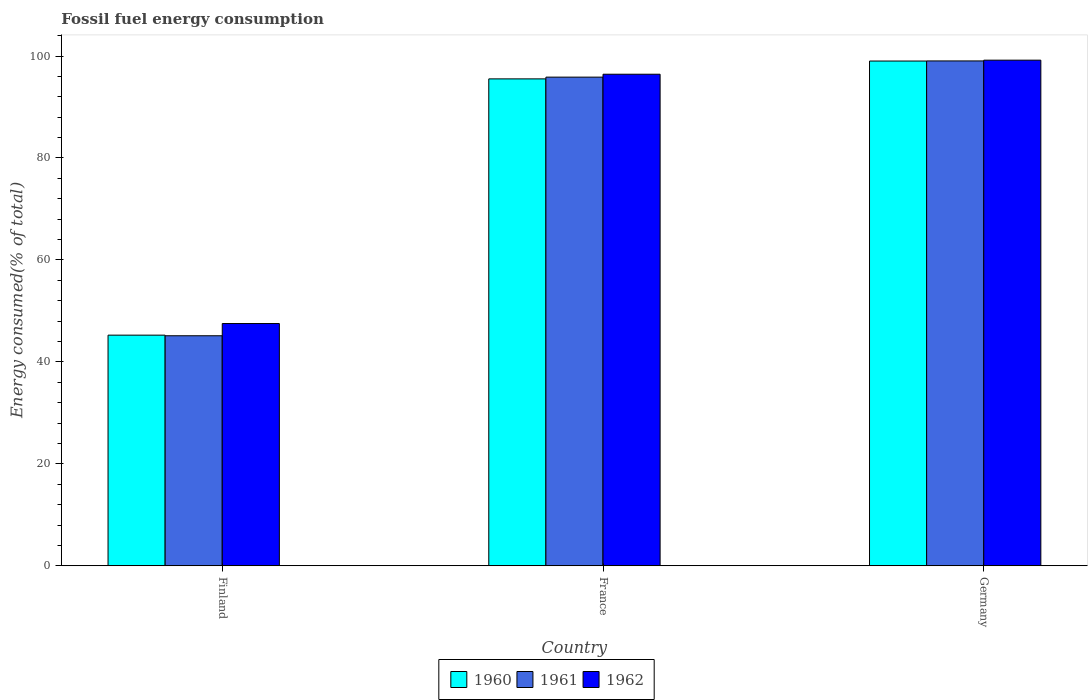How many groups of bars are there?
Make the answer very short. 3. How many bars are there on the 3rd tick from the left?
Give a very brief answer. 3. What is the label of the 3rd group of bars from the left?
Your answer should be compact. Germany. In how many cases, is the number of bars for a given country not equal to the number of legend labels?
Make the answer very short. 0. What is the percentage of energy consumed in 1961 in Germany?
Provide a short and direct response. 99.04. Across all countries, what is the maximum percentage of energy consumed in 1960?
Make the answer very short. 99.02. Across all countries, what is the minimum percentage of energy consumed in 1960?
Your answer should be compact. 45.25. In which country was the percentage of energy consumed in 1962 maximum?
Ensure brevity in your answer.  Germany. In which country was the percentage of energy consumed in 1960 minimum?
Your response must be concise. Finland. What is the total percentage of energy consumed in 1962 in the graph?
Keep it short and to the point. 243.15. What is the difference between the percentage of energy consumed in 1961 in Finland and that in France?
Provide a succinct answer. -50.73. What is the difference between the percentage of energy consumed in 1961 in Germany and the percentage of energy consumed in 1962 in France?
Keep it short and to the point. 2.61. What is the average percentage of energy consumed in 1961 per country?
Ensure brevity in your answer.  80.01. What is the difference between the percentage of energy consumed of/in 1960 and percentage of energy consumed of/in 1962 in Germany?
Give a very brief answer. -0.17. What is the ratio of the percentage of energy consumed in 1961 in France to that in Germany?
Provide a succinct answer. 0.97. What is the difference between the highest and the second highest percentage of energy consumed in 1961?
Offer a very short reply. 53.91. What is the difference between the highest and the lowest percentage of energy consumed in 1962?
Offer a very short reply. 51.67. In how many countries, is the percentage of energy consumed in 1962 greater than the average percentage of energy consumed in 1962 taken over all countries?
Offer a very short reply. 2. Is the sum of the percentage of energy consumed in 1961 in France and Germany greater than the maximum percentage of energy consumed in 1962 across all countries?
Provide a short and direct response. Yes. Are all the bars in the graph horizontal?
Keep it short and to the point. No. Are the values on the major ticks of Y-axis written in scientific E-notation?
Your answer should be compact. No. Does the graph contain any zero values?
Make the answer very short. No. Does the graph contain grids?
Provide a succinct answer. No. How many legend labels are there?
Give a very brief answer. 3. How are the legend labels stacked?
Ensure brevity in your answer.  Horizontal. What is the title of the graph?
Keep it short and to the point. Fossil fuel energy consumption. Does "1978" appear as one of the legend labels in the graph?
Make the answer very short. No. What is the label or title of the X-axis?
Offer a terse response. Country. What is the label or title of the Y-axis?
Give a very brief answer. Energy consumed(% of total). What is the Energy consumed(% of total) in 1960 in Finland?
Keep it short and to the point. 45.25. What is the Energy consumed(% of total) of 1961 in Finland?
Offer a very short reply. 45.13. What is the Energy consumed(% of total) of 1962 in Finland?
Offer a terse response. 47.52. What is the Energy consumed(% of total) of 1960 in France?
Your response must be concise. 95.52. What is the Energy consumed(% of total) in 1961 in France?
Ensure brevity in your answer.  95.86. What is the Energy consumed(% of total) of 1962 in France?
Provide a short and direct response. 96.43. What is the Energy consumed(% of total) in 1960 in Germany?
Make the answer very short. 99.02. What is the Energy consumed(% of total) in 1961 in Germany?
Offer a terse response. 99.04. What is the Energy consumed(% of total) of 1962 in Germany?
Your answer should be compact. 99.19. Across all countries, what is the maximum Energy consumed(% of total) of 1960?
Your response must be concise. 99.02. Across all countries, what is the maximum Energy consumed(% of total) in 1961?
Offer a very short reply. 99.04. Across all countries, what is the maximum Energy consumed(% of total) in 1962?
Keep it short and to the point. 99.19. Across all countries, what is the minimum Energy consumed(% of total) in 1960?
Offer a terse response. 45.25. Across all countries, what is the minimum Energy consumed(% of total) in 1961?
Provide a succinct answer. 45.13. Across all countries, what is the minimum Energy consumed(% of total) of 1962?
Offer a very short reply. 47.52. What is the total Energy consumed(% of total) of 1960 in the graph?
Ensure brevity in your answer.  239.79. What is the total Energy consumed(% of total) in 1961 in the graph?
Keep it short and to the point. 240.03. What is the total Energy consumed(% of total) of 1962 in the graph?
Offer a very short reply. 243.15. What is the difference between the Energy consumed(% of total) in 1960 in Finland and that in France?
Provide a succinct answer. -50.27. What is the difference between the Energy consumed(% of total) of 1961 in Finland and that in France?
Keep it short and to the point. -50.73. What is the difference between the Energy consumed(% of total) of 1962 in Finland and that in France?
Provide a succinct answer. -48.91. What is the difference between the Energy consumed(% of total) in 1960 in Finland and that in Germany?
Your answer should be compact. -53.77. What is the difference between the Energy consumed(% of total) in 1961 in Finland and that in Germany?
Keep it short and to the point. -53.91. What is the difference between the Energy consumed(% of total) of 1962 in Finland and that in Germany?
Offer a terse response. -51.67. What is the difference between the Energy consumed(% of total) in 1961 in France and that in Germany?
Provide a succinct answer. -3.18. What is the difference between the Energy consumed(% of total) in 1962 in France and that in Germany?
Your answer should be compact. -2.76. What is the difference between the Energy consumed(% of total) of 1960 in Finland and the Energy consumed(% of total) of 1961 in France?
Your response must be concise. -50.62. What is the difference between the Energy consumed(% of total) of 1960 in Finland and the Energy consumed(% of total) of 1962 in France?
Ensure brevity in your answer.  -51.19. What is the difference between the Energy consumed(% of total) of 1961 in Finland and the Energy consumed(% of total) of 1962 in France?
Offer a very short reply. -51.3. What is the difference between the Energy consumed(% of total) of 1960 in Finland and the Energy consumed(% of total) of 1961 in Germany?
Ensure brevity in your answer.  -53.8. What is the difference between the Energy consumed(% of total) in 1960 in Finland and the Energy consumed(% of total) in 1962 in Germany?
Your response must be concise. -53.95. What is the difference between the Energy consumed(% of total) of 1961 in Finland and the Energy consumed(% of total) of 1962 in Germany?
Make the answer very short. -54.06. What is the difference between the Energy consumed(% of total) in 1960 in France and the Energy consumed(% of total) in 1961 in Germany?
Offer a terse response. -3.52. What is the difference between the Energy consumed(% of total) in 1960 in France and the Energy consumed(% of total) in 1962 in Germany?
Your answer should be very brief. -3.67. What is the difference between the Energy consumed(% of total) in 1961 in France and the Energy consumed(% of total) in 1962 in Germany?
Keep it short and to the point. -3.33. What is the average Energy consumed(% of total) of 1960 per country?
Offer a very short reply. 79.93. What is the average Energy consumed(% of total) in 1961 per country?
Your answer should be compact. 80.01. What is the average Energy consumed(% of total) of 1962 per country?
Your answer should be compact. 81.05. What is the difference between the Energy consumed(% of total) in 1960 and Energy consumed(% of total) in 1961 in Finland?
Ensure brevity in your answer.  0.12. What is the difference between the Energy consumed(% of total) in 1960 and Energy consumed(% of total) in 1962 in Finland?
Give a very brief answer. -2.28. What is the difference between the Energy consumed(% of total) of 1961 and Energy consumed(% of total) of 1962 in Finland?
Offer a very short reply. -2.4. What is the difference between the Energy consumed(% of total) of 1960 and Energy consumed(% of total) of 1961 in France?
Ensure brevity in your answer.  -0.34. What is the difference between the Energy consumed(% of total) in 1960 and Energy consumed(% of total) in 1962 in France?
Offer a terse response. -0.91. What is the difference between the Energy consumed(% of total) of 1961 and Energy consumed(% of total) of 1962 in France?
Your answer should be compact. -0.57. What is the difference between the Energy consumed(% of total) of 1960 and Energy consumed(% of total) of 1961 in Germany?
Offer a very short reply. -0.02. What is the difference between the Energy consumed(% of total) of 1960 and Energy consumed(% of total) of 1962 in Germany?
Offer a very short reply. -0.17. What is the difference between the Energy consumed(% of total) in 1961 and Energy consumed(% of total) in 1962 in Germany?
Provide a short and direct response. -0.15. What is the ratio of the Energy consumed(% of total) of 1960 in Finland to that in France?
Provide a short and direct response. 0.47. What is the ratio of the Energy consumed(% of total) in 1961 in Finland to that in France?
Your answer should be compact. 0.47. What is the ratio of the Energy consumed(% of total) in 1962 in Finland to that in France?
Offer a very short reply. 0.49. What is the ratio of the Energy consumed(% of total) in 1960 in Finland to that in Germany?
Make the answer very short. 0.46. What is the ratio of the Energy consumed(% of total) in 1961 in Finland to that in Germany?
Make the answer very short. 0.46. What is the ratio of the Energy consumed(% of total) in 1962 in Finland to that in Germany?
Keep it short and to the point. 0.48. What is the ratio of the Energy consumed(% of total) in 1960 in France to that in Germany?
Your answer should be very brief. 0.96. What is the ratio of the Energy consumed(% of total) of 1961 in France to that in Germany?
Your answer should be very brief. 0.97. What is the ratio of the Energy consumed(% of total) in 1962 in France to that in Germany?
Provide a succinct answer. 0.97. What is the difference between the highest and the second highest Energy consumed(% of total) in 1960?
Your answer should be compact. 3.5. What is the difference between the highest and the second highest Energy consumed(% of total) in 1961?
Your answer should be very brief. 3.18. What is the difference between the highest and the second highest Energy consumed(% of total) in 1962?
Offer a terse response. 2.76. What is the difference between the highest and the lowest Energy consumed(% of total) in 1960?
Offer a terse response. 53.77. What is the difference between the highest and the lowest Energy consumed(% of total) in 1961?
Offer a terse response. 53.91. What is the difference between the highest and the lowest Energy consumed(% of total) in 1962?
Offer a terse response. 51.67. 